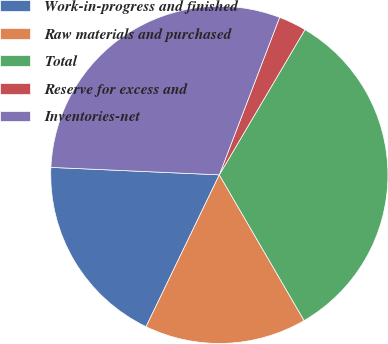<chart> <loc_0><loc_0><loc_500><loc_500><pie_chart><fcel>Work-in-progress and finished<fcel>Raw materials and purchased<fcel>Total<fcel>Reserve for excess and<fcel>Inventories-net<nl><fcel>18.55%<fcel>15.54%<fcel>33.13%<fcel>2.66%<fcel>30.11%<nl></chart> 